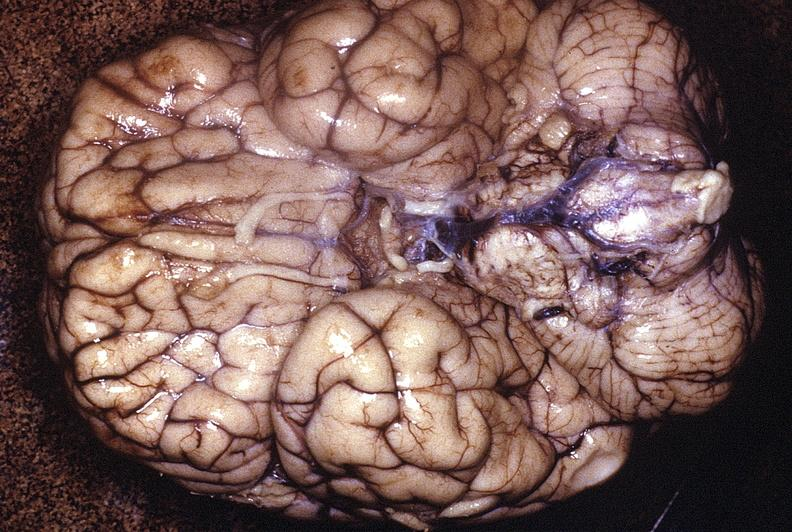what does this image show?
Answer the question using a single word or phrase. Normal brain 